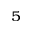Convert formula to latex. <formula><loc_0><loc_0><loc_500><loc_500>^ { 5 }</formula> 